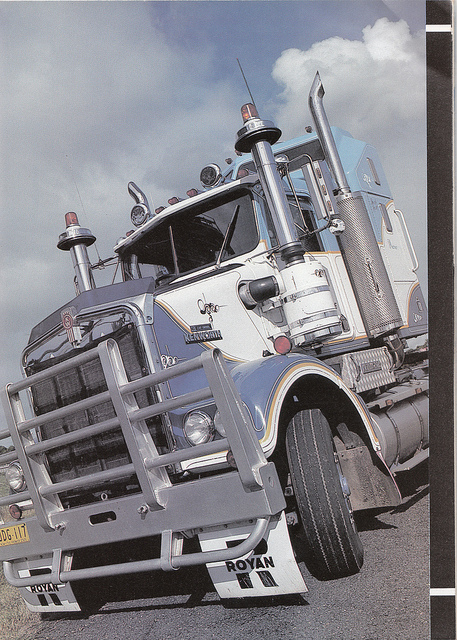Identify and read out the text in this image. ROYAN 